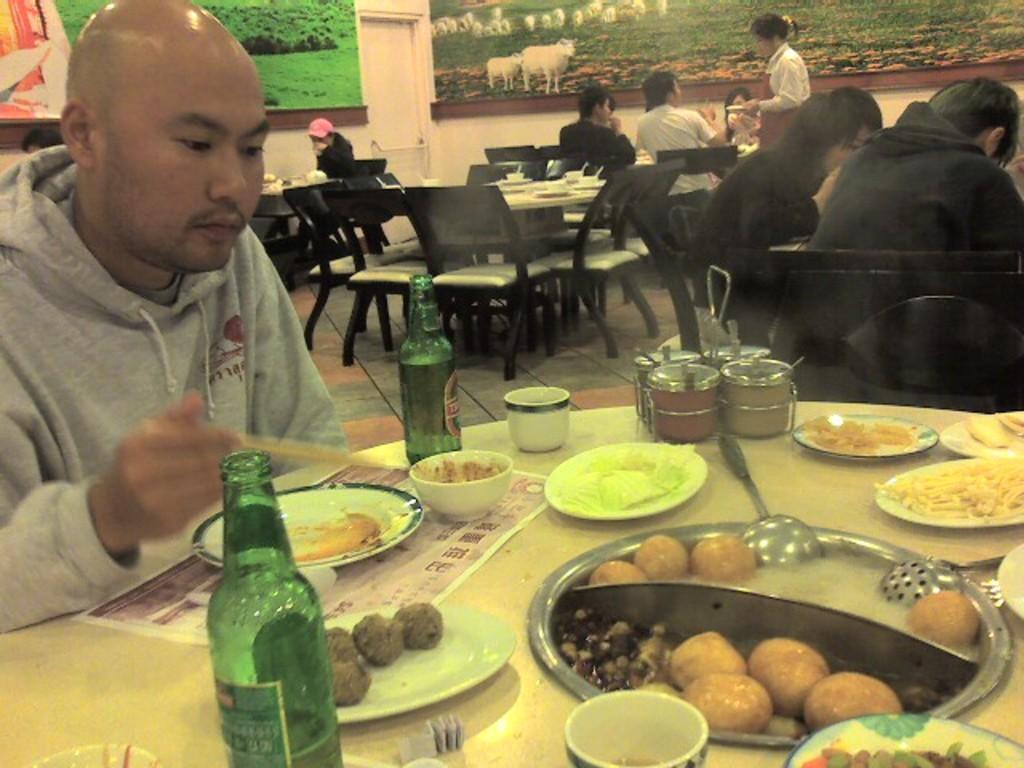Can you describe this image briefly? There are food items, bottles and plates are present on a table as we can see at the bottom of this image. There is one person sitting on the left side of this image and we can see tables, chairs and a group of people in the middle of this image. We can see photo frames attached to the wall which is in the background. 